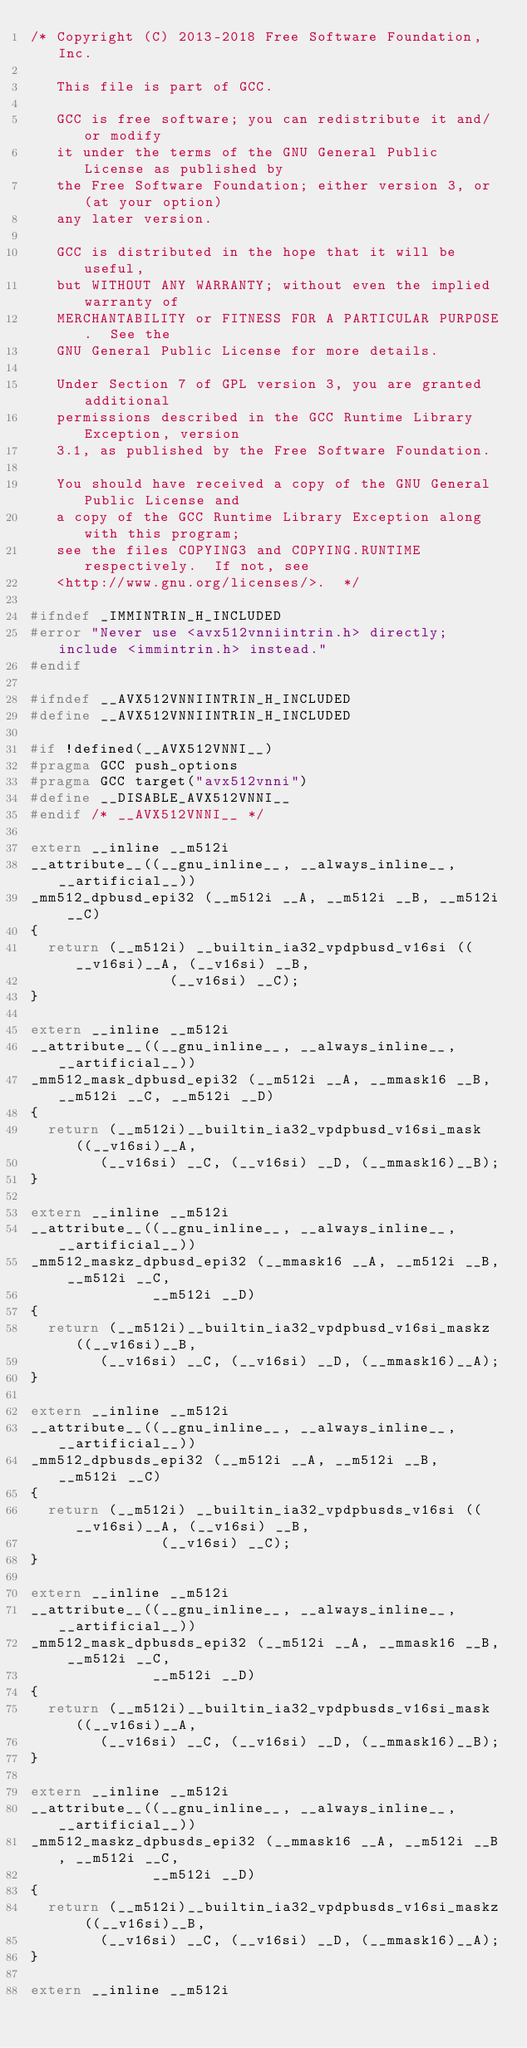<code> <loc_0><loc_0><loc_500><loc_500><_C_>/* Copyright (C) 2013-2018 Free Software Foundation, Inc.

   This file is part of GCC.

   GCC is free software; you can redistribute it and/or modify
   it under the terms of the GNU General Public License as published by
   the Free Software Foundation; either version 3, or (at your option)
   any later version.

   GCC is distributed in the hope that it will be useful,
   but WITHOUT ANY WARRANTY; without even the implied warranty of
   MERCHANTABILITY or FITNESS FOR A PARTICULAR PURPOSE.  See the
   GNU General Public License for more details.

   Under Section 7 of GPL version 3, you are granted additional
   permissions described in the GCC Runtime Library Exception, version
   3.1, as published by the Free Software Foundation.

   You should have received a copy of the GNU General Public License and
   a copy of the GCC Runtime Library Exception along with this program;
   see the files COPYING3 and COPYING.RUNTIME respectively.  If not, see
   <http://www.gnu.org/licenses/>.  */

#ifndef _IMMINTRIN_H_INCLUDED
#error "Never use <avx512vnniintrin.h> directly; include <immintrin.h> instead."
#endif

#ifndef __AVX512VNNIINTRIN_H_INCLUDED
#define __AVX512VNNIINTRIN_H_INCLUDED

#if !defined(__AVX512VNNI__)
#pragma GCC push_options
#pragma GCC target("avx512vnni")
#define __DISABLE_AVX512VNNI__
#endif /* __AVX512VNNI__ */

extern __inline __m512i
__attribute__((__gnu_inline__, __always_inline__, __artificial__))
_mm512_dpbusd_epi32 (__m512i __A, __m512i __B, __m512i __C)
{
  return (__m512i) __builtin_ia32_vpdpbusd_v16si ((__v16si)__A, (__v16si) __B,
								(__v16si) __C);
}

extern __inline __m512i
__attribute__((__gnu_inline__, __always_inline__, __artificial__))
_mm512_mask_dpbusd_epi32 (__m512i __A, __mmask16 __B, __m512i __C, __m512i __D)
{
  return (__m512i)__builtin_ia32_vpdpbusd_v16si_mask ((__v16si)__A,
				(__v16si) __C, (__v16si) __D, (__mmask16)__B);
}

extern __inline __m512i
__attribute__((__gnu_inline__, __always_inline__, __artificial__))
_mm512_maskz_dpbusd_epi32 (__mmask16 __A, __m512i __B, __m512i __C,
							__m512i __D)
{
  return (__m512i)__builtin_ia32_vpdpbusd_v16si_maskz ((__v16si)__B,
				(__v16si) __C, (__v16si) __D, (__mmask16)__A);
}

extern __inline __m512i
__attribute__((__gnu_inline__, __always_inline__, __artificial__))
_mm512_dpbusds_epi32 (__m512i __A, __m512i __B, __m512i __C)
{
  return (__m512i) __builtin_ia32_vpdpbusds_v16si ((__v16si)__A, (__v16si) __B,
							 (__v16si) __C);
}

extern __inline __m512i
__attribute__((__gnu_inline__, __always_inline__, __artificial__))
_mm512_mask_dpbusds_epi32 (__m512i __A, __mmask16 __B, __m512i __C,
							__m512i __D)
{
  return (__m512i)__builtin_ia32_vpdpbusds_v16si_mask ((__v16si)__A,
				(__v16si) __C, (__v16si) __D, (__mmask16)__B);
}

extern __inline __m512i
__attribute__((__gnu_inline__, __always_inline__, __artificial__))
_mm512_maskz_dpbusds_epi32 (__mmask16 __A, __m512i __B, __m512i __C,
							__m512i __D)
{
  return (__m512i)__builtin_ia32_vpdpbusds_v16si_maskz ((__v16si)__B,
				(__v16si) __C, (__v16si) __D, (__mmask16)__A);
}

extern __inline __m512i</code> 